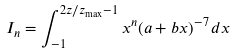<formula> <loc_0><loc_0><loc_500><loc_500>I _ { n } = \int _ { - 1 } ^ { 2 z / z _ { \max } - 1 } x ^ { n } ( a + b x ) ^ { - 7 } \, d x</formula> 